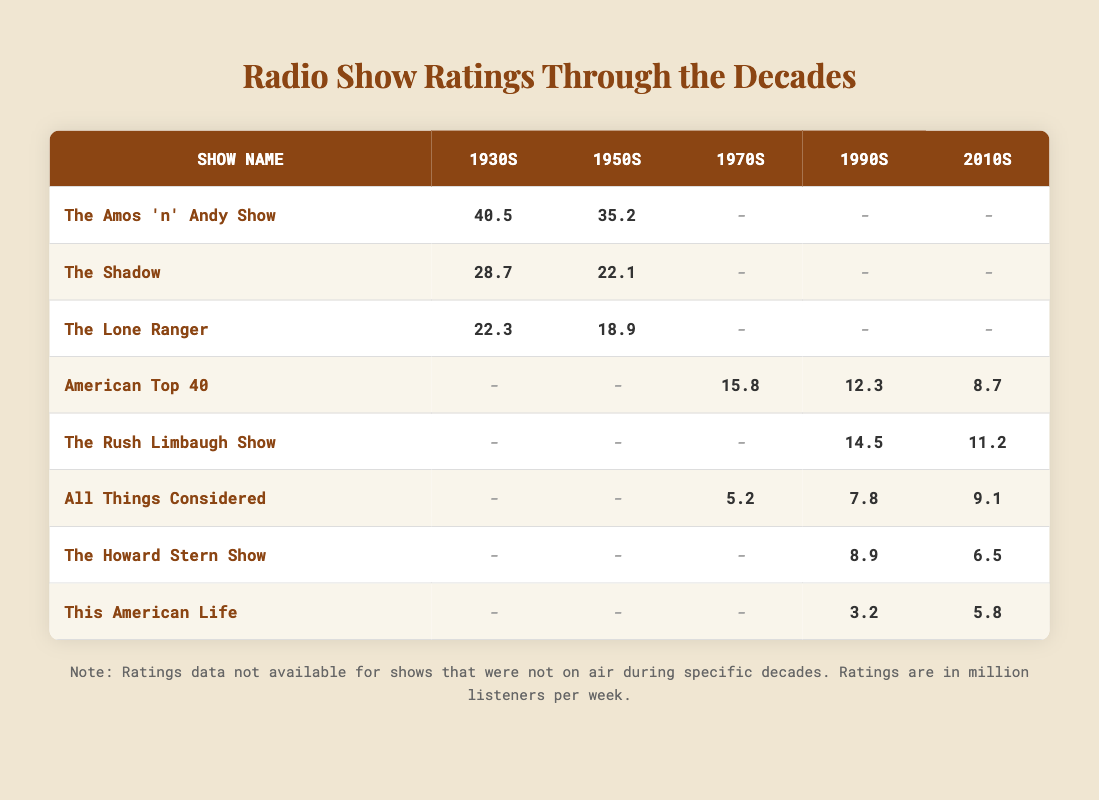What was the highest rating achieved by "The Amos 'n' Andy Show"? The highest rating for "The Amos 'n' Andy Show" can be found in the 1930s column, where it shows 40.5 million listeners.
Answer: 40.5 Which show had a rating of 18.9 million listeners in the 1950s? In the 1950s column, "The Lone Ranger" is the only show that has a rating of 18.9 million listeners.
Answer: The Lone Ranger What is the trend in ratings for "All Things Considered" from the 1990s to the 2010s? The ratings for "All Things Considered" increase from 7.8 million listeners in the 1990s to 9.1 million listeners in the 2010s.
Answer: Increasing Is there any data for "The Howard Stern Show" in the 1970s? "The Howard Stern Show" does not have any rating data listed for the 1970s, as it is marked with a dash.
Answer: No What is the average rating for "American Top 40" across the decades it was aired? The ratings available are 15.8 (1970s), 12.3 (1990s), and 8.7 (2010s). Adding these gives 36.8, and dividing by 3 yields an average of 12.27 million listeners.
Answer: 12.27 How many shows were rated in the 1930s and what’s the highest rating among them? In the 1930s, there are three shows listed: "The Amos 'n' Andy Show" (40.5), "The Shadow" (28.7), and "The Lone Ranger" (22.3). The highest rating is from "The Amos 'n' Andy Show" at 40.5 million listeners.
Answer: 3 shows, highest is 40.5 Was "This American Life" ever rated higher than 5 million listeners in any decade? "This American Life" had ratings of 3.2 million and 5.8 million in the 2010s, making the highest rating 5.8 million, which is above 5 million listeners.
Answer: Yes In which decade did "The Rush Limbaugh Show" show a decline in ratings? The ratings for "The Rush Limbaugh Show" start at 14.5 million in the 1990s and drop to 11.2 million in the 2010s, indicating a decline.
Answer: 2010s 